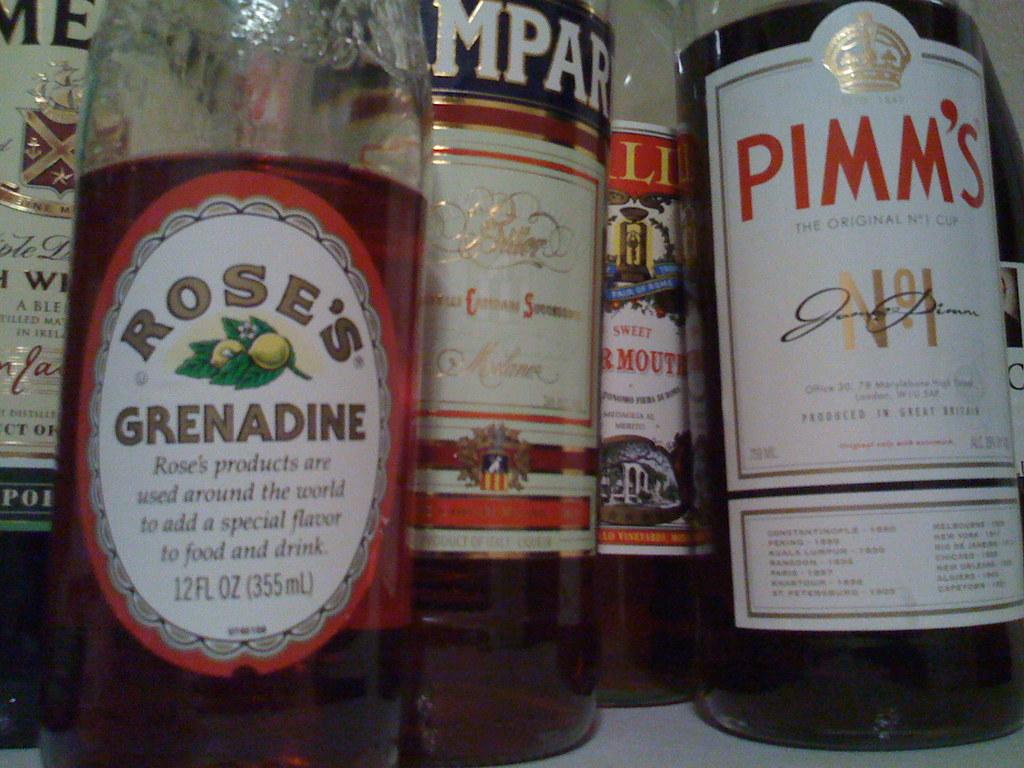How many ounces are in the grenadine?
Offer a very short reply. 12. What brad of grenadine is this?
Your response must be concise. Rose's. 